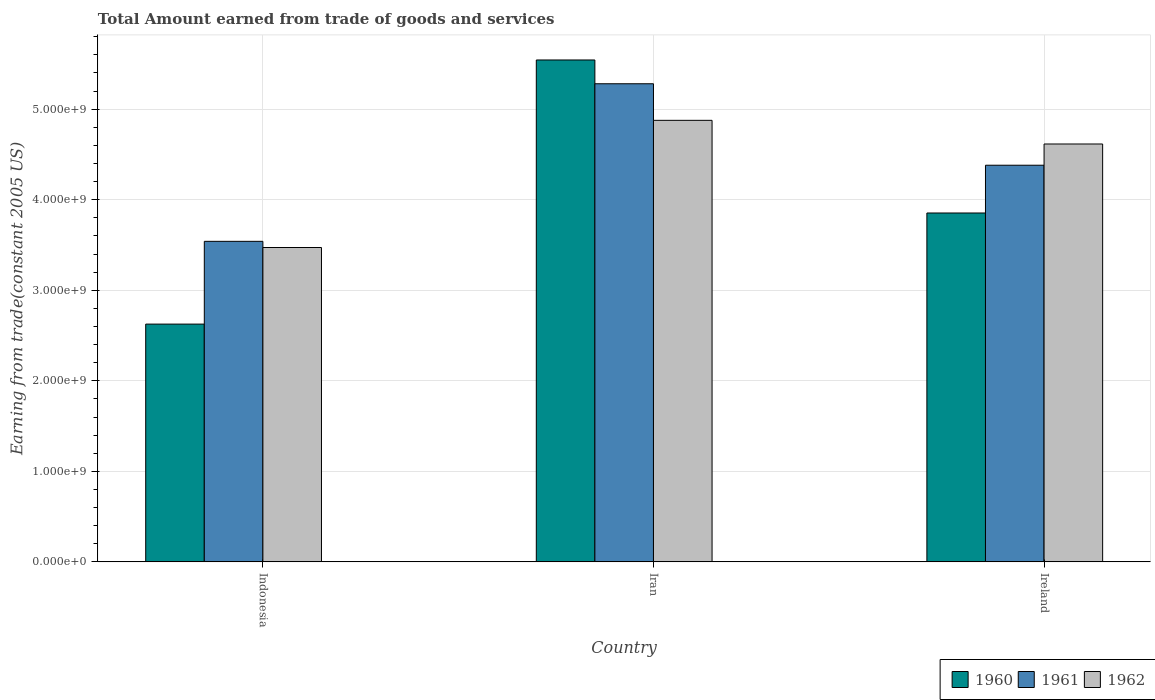How many different coloured bars are there?
Provide a short and direct response. 3. How many groups of bars are there?
Provide a succinct answer. 3. Are the number of bars on each tick of the X-axis equal?
Keep it short and to the point. Yes. How many bars are there on the 2nd tick from the left?
Your response must be concise. 3. What is the label of the 1st group of bars from the left?
Provide a short and direct response. Indonesia. What is the total amount earned by trading goods and services in 1961 in Iran?
Give a very brief answer. 5.28e+09. Across all countries, what is the maximum total amount earned by trading goods and services in 1960?
Make the answer very short. 5.54e+09. Across all countries, what is the minimum total amount earned by trading goods and services in 1961?
Your answer should be very brief. 3.54e+09. In which country was the total amount earned by trading goods and services in 1962 maximum?
Give a very brief answer. Iran. What is the total total amount earned by trading goods and services in 1960 in the graph?
Your answer should be compact. 1.20e+1. What is the difference between the total amount earned by trading goods and services in 1960 in Iran and that in Ireland?
Ensure brevity in your answer.  1.69e+09. What is the difference between the total amount earned by trading goods and services in 1960 in Iran and the total amount earned by trading goods and services in 1962 in Indonesia?
Your answer should be very brief. 2.07e+09. What is the average total amount earned by trading goods and services in 1961 per country?
Your answer should be compact. 4.40e+09. What is the difference between the total amount earned by trading goods and services of/in 1960 and total amount earned by trading goods and services of/in 1962 in Indonesia?
Keep it short and to the point. -8.46e+08. What is the ratio of the total amount earned by trading goods and services in 1961 in Iran to that in Ireland?
Give a very brief answer. 1.21. Is the total amount earned by trading goods and services in 1962 in Iran less than that in Ireland?
Give a very brief answer. No. What is the difference between the highest and the second highest total amount earned by trading goods and services in 1961?
Your answer should be compact. -1.74e+09. What is the difference between the highest and the lowest total amount earned by trading goods and services in 1961?
Provide a short and direct response. 1.74e+09. Is the sum of the total amount earned by trading goods and services in 1961 in Indonesia and Ireland greater than the maximum total amount earned by trading goods and services in 1962 across all countries?
Offer a very short reply. Yes. Does the graph contain any zero values?
Provide a short and direct response. No. Does the graph contain grids?
Ensure brevity in your answer.  Yes. Where does the legend appear in the graph?
Your answer should be compact. Bottom right. What is the title of the graph?
Provide a short and direct response. Total Amount earned from trade of goods and services. Does "2006" appear as one of the legend labels in the graph?
Provide a succinct answer. No. What is the label or title of the X-axis?
Offer a terse response. Country. What is the label or title of the Y-axis?
Give a very brief answer. Earning from trade(constant 2005 US). What is the Earning from trade(constant 2005 US) of 1960 in Indonesia?
Your response must be concise. 2.63e+09. What is the Earning from trade(constant 2005 US) of 1961 in Indonesia?
Ensure brevity in your answer.  3.54e+09. What is the Earning from trade(constant 2005 US) of 1962 in Indonesia?
Keep it short and to the point. 3.47e+09. What is the Earning from trade(constant 2005 US) of 1960 in Iran?
Your answer should be compact. 5.54e+09. What is the Earning from trade(constant 2005 US) in 1961 in Iran?
Your answer should be compact. 5.28e+09. What is the Earning from trade(constant 2005 US) of 1962 in Iran?
Provide a succinct answer. 4.88e+09. What is the Earning from trade(constant 2005 US) in 1960 in Ireland?
Make the answer very short. 3.85e+09. What is the Earning from trade(constant 2005 US) in 1961 in Ireland?
Your answer should be compact. 4.38e+09. What is the Earning from trade(constant 2005 US) of 1962 in Ireland?
Your answer should be very brief. 4.62e+09. Across all countries, what is the maximum Earning from trade(constant 2005 US) in 1960?
Keep it short and to the point. 5.54e+09. Across all countries, what is the maximum Earning from trade(constant 2005 US) in 1961?
Your response must be concise. 5.28e+09. Across all countries, what is the maximum Earning from trade(constant 2005 US) in 1962?
Provide a short and direct response. 4.88e+09. Across all countries, what is the minimum Earning from trade(constant 2005 US) of 1960?
Offer a very short reply. 2.63e+09. Across all countries, what is the minimum Earning from trade(constant 2005 US) of 1961?
Your answer should be compact. 3.54e+09. Across all countries, what is the minimum Earning from trade(constant 2005 US) of 1962?
Your response must be concise. 3.47e+09. What is the total Earning from trade(constant 2005 US) in 1960 in the graph?
Give a very brief answer. 1.20e+1. What is the total Earning from trade(constant 2005 US) of 1961 in the graph?
Ensure brevity in your answer.  1.32e+1. What is the total Earning from trade(constant 2005 US) in 1962 in the graph?
Provide a short and direct response. 1.30e+1. What is the difference between the Earning from trade(constant 2005 US) in 1960 in Indonesia and that in Iran?
Make the answer very short. -2.92e+09. What is the difference between the Earning from trade(constant 2005 US) in 1961 in Indonesia and that in Iran?
Give a very brief answer. -1.74e+09. What is the difference between the Earning from trade(constant 2005 US) in 1962 in Indonesia and that in Iran?
Ensure brevity in your answer.  -1.40e+09. What is the difference between the Earning from trade(constant 2005 US) of 1960 in Indonesia and that in Ireland?
Ensure brevity in your answer.  -1.23e+09. What is the difference between the Earning from trade(constant 2005 US) of 1961 in Indonesia and that in Ireland?
Make the answer very short. -8.41e+08. What is the difference between the Earning from trade(constant 2005 US) of 1962 in Indonesia and that in Ireland?
Give a very brief answer. -1.14e+09. What is the difference between the Earning from trade(constant 2005 US) in 1960 in Iran and that in Ireland?
Offer a terse response. 1.69e+09. What is the difference between the Earning from trade(constant 2005 US) of 1961 in Iran and that in Ireland?
Your response must be concise. 9.00e+08. What is the difference between the Earning from trade(constant 2005 US) in 1962 in Iran and that in Ireland?
Offer a terse response. 2.61e+08. What is the difference between the Earning from trade(constant 2005 US) of 1960 in Indonesia and the Earning from trade(constant 2005 US) of 1961 in Iran?
Make the answer very short. -2.65e+09. What is the difference between the Earning from trade(constant 2005 US) of 1960 in Indonesia and the Earning from trade(constant 2005 US) of 1962 in Iran?
Your answer should be very brief. -2.25e+09. What is the difference between the Earning from trade(constant 2005 US) of 1961 in Indonesia and the Earning from trade(constant 2005 US) of 1962 in Iran?
Make the answer very short. -1.34e+09. What is the difference between the Earning from trade(constant 2005 US) in 1960 in Indonesia and the Earning from trade(constant 2005 US) in 1961 in Ireland?
Offer a very short reply. -1.75e+09. What is the difference between the Earning from trade(constant 2005 US) of 1960 in Indonesia and the Earning from trade(constant 2005 US) of 1962 in Ireland?
Give a very brief answer. -1.99e+09. What is the difference between the Earning from trade(constant 2005 US) of 1961 in Indonesia and the Earning from trade(constant 2005 US) of 1962 in Ireland?
Your answer should be very brief. -1.08e+09. What is the difference between the Earning from trade(constant 2005 US) in 1960 in Iran and the Earning from trade(constant 2005 US) in 1961 in Ireland?
Offer a terse response. 1.16e+09. What is the difference between the Earning from trade(constant 2005 US) in 1960 in Iran and the Earning from trade(constant 2005 US) in 1962 in Ireland?
Provide a succinct answer. 9.28e+08. What is the difference between the Earning from trade(constant 2005 US) in 1961 in Iran and the Earning from trade(constant 2005 US) in 1962 in Ireland?
Give a very brief answer. 6.65e+08. What is the average Earning from trade(constant 2005 US) of 1960 per country?
Your response must be concise. 4.01e+09. What is the average Earning from trade(constant 2005 US) in 1961 per country?
Give a very brief answer. 4.40e+09. What is the average Earning from trade(constant 2005 US) in 1962 per country?
Your response must be concise. 4.32e+09. What is the difference between the Earning from trade(constant 2005 US) of 1960 and Earning from trade(constant 2005 US) of 1961 in Indonesia?
Provide a short and direct response. -9.14e+08. What is the difference between the Earning from trade(constant 2005 US) of 1960 and Earning from trade(constant 2005 US) of 1962 in Indonesia?
Provide a short and direct response. -8.46e+08. What is the difference between the Earning from trade(constant 2005 US) in 1961 and Earning from trade(constant 2005 US) in 1962 in Indonesia?
Your answer should be compact. 6.82e+07. What is the difference between the Earning from trade(constant 2005 US) of 1960 and Earning from trade(constant 2005 US) of 1961 in Iran?
Give a very brief answer. 2.63e+08. What is the difference between the Earning from trade(constant 2005 US) of 1960 and Earning from trade(constant 2005 US) of 1962 in Iran?
Provide a short and direct response. 6.67e+08. What is the difference between the Earning from trade(constant 2005 US) in 1961 and Earning from trade(constant 2005 US) in 1962 in Iran?
Provide a short and direct response. 4.04e+08. What is the difference between the Earning from trade(constant 2005 US) in 1960 and Earning from trade(constant 2005 US) in 1961 in Ireland?
Provide a succinct answer. -5.28e+08. What is the difference between the Earning from trade(constant 2005 US) in 1960 and Earning from trade(constant 2005 US) in 1962 in Ireland?
Your response must be concise. -7.62e+08. What is the difference between the Earning from trade(constant 2005 US) of 1961 and Earning from trade(constant 2005 US) of 1962 in Ireland?
Offer a terse response. -2.34e+08. What is the ratio of the Earning from trade(constant 2005 US) of 1960 in Indonesia to that in Iran?
Your answer should be compact. 0.47. What is the ratio of the Earning from trade(constant 2005 US) of 1961 in Indonesia to that in Iran?
Make the answer very short. 0.67. What is the ratio of the Earning from trade(constant 2005 US) in 1962 in Indonesia to that in Iran?
Offer a terse response. 0.71. What is the ratio of the Earning from trade(constant 2005 US) of 1960 in Indonesia to that in Ireland?
Your response must be concise. 0.68. What is the ratio of the Earning from trade(constant 2005 US) in 1961 in Indonesia to that in Ireland?
Give a very brief answer. 0.81. What is the ratio of the Earning from trade(constant 2005 US) of 1962 in Indonesia to that in Ireland?
Ensure brevity in your answer.  0.75. What is the ratio of the Earning from trade(constant 2005 US) of 1960 in Iran to that in Ireland?
Keep it short and to the point. 1.44. What is the ratio of the Earning from trade(constant 2005 US) of 1961 in Iran to that in Ireland?
Provide a short and direct response. 1.21. What is the ratio of the Earning from trade(constant 2005 US) of 1962 in Iran to that in Ireland?
Your response must be concise. 1.06. What is the difference between the highest and the second highest Earning from trade(constant 2005 US) of 1960?
Offer a very short reply. 1.69e+09. What is the difference between the highest and the second highest Earning from trade(constant 2005 US) of 1961?
Your response must be concise. 9.00e+08. What is the difference between the highest and the second highest Earning from trade(constant 2005 US) in 1962?
Provide a short and direct response. 2.61e+08. What is the difference between the highest and the lowest Earning from trade(constant 2005 US) of 1960?
Ensure brevity in your answer.  2.92e+09. What is the difference between the highest and the lowest Earning from trade(constant 2005 US) of 1961?
Give a very brief answer. 1.74e+09. What is the difference between the highest and the lowest Earning from trade(constant 2005 US) in 1962?
Keep it short and to the point. 1.40e+09. 